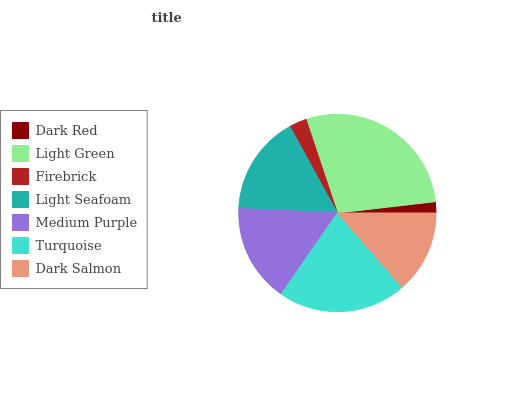Is Dark Red the minimum?
Answer yes or no. Yes. Is Light Green the maximum?
Answer yes or no. Yes. Is Firebrick the minimum?
Answer yes or no. No. Is Firebrick the maximum?
Answer yes or no. No. Is Light Green greater than Firebrick?
Answer yes or no. Yes. Is Firebrick less than Light Green?
Answer yes or no. Yes. Is Firebrick greater than Light Green?
Answer yes or no. No. Is Light Green less than Firebrick?
Answer yes or no. No. Is Medium Purple the high median?
Answer yes or no. Yes. Is Medium Purple the low median?
Answer yes or no. Yes. Is Dark Red the high median?
Answer yes or no. No. Is Dark Red the low median?
Answer yes or no. No. 